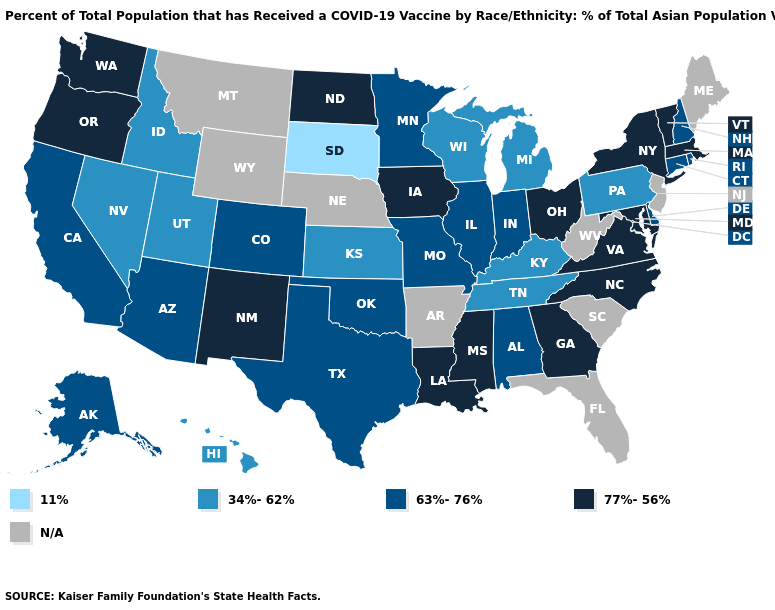Among the states that border Washington , which have the lowest value?
Short answer required. Idaho. Among the states that border New Mexico , which have the highest value?
Give a very brief answer. Arizona, Colorado, Oklahoma, Texas. Which states have the lowest value in the USA?
Concise answer only. South Dakota. Which states hav the highest value in the Northeast?
Be succinct. Massachusetts, New York, Vermont. What is the highest value in the Northeast ?
Concise answer only. 77%-56%. Does Hawaii have the highest value in the West?
Write a very short answer. No. What is the lowest value in the South?
Write a very short answer. 34%-62%. Does the first symbol in the legend represent the smallest category?
Short answer required. Yes. What is the value of Pennsylvania?
Answer briefly. 34%-62%. How many symbols are there in the legend?
Answer briefly. 5. Which states hav the highest value in the South?
Keep it brief. Georgia, Louisiana, Maryland, Mississippi, North Carolina, Virginia. Among the states that border New Jersey , does New York have the lowest value?
Answer briefly. No. 